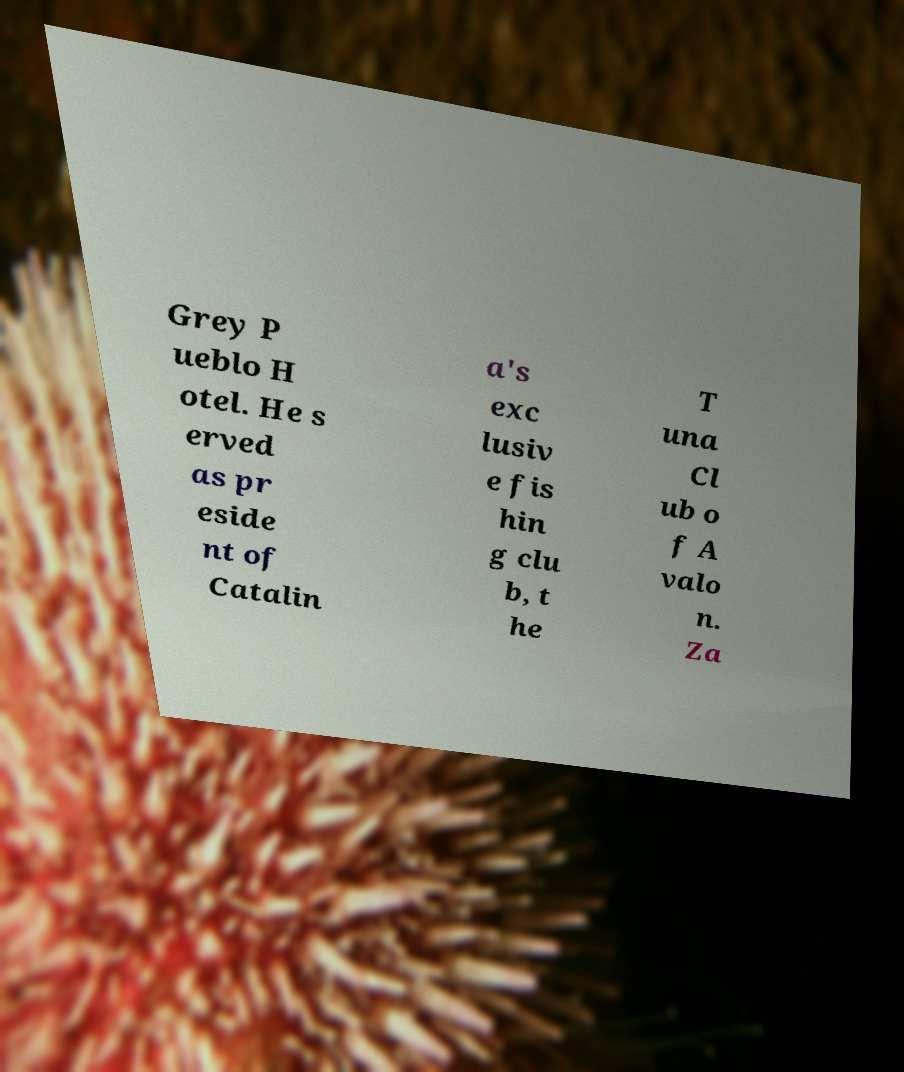Could you assist in decoding the text presented in this image and type it out clearly? Grey P ueblo H otel. He s erved as pr eside nt of Catalin a's exc lusiv e fis hin g clu b, t he T una Cl ub o f A valo n. Za 